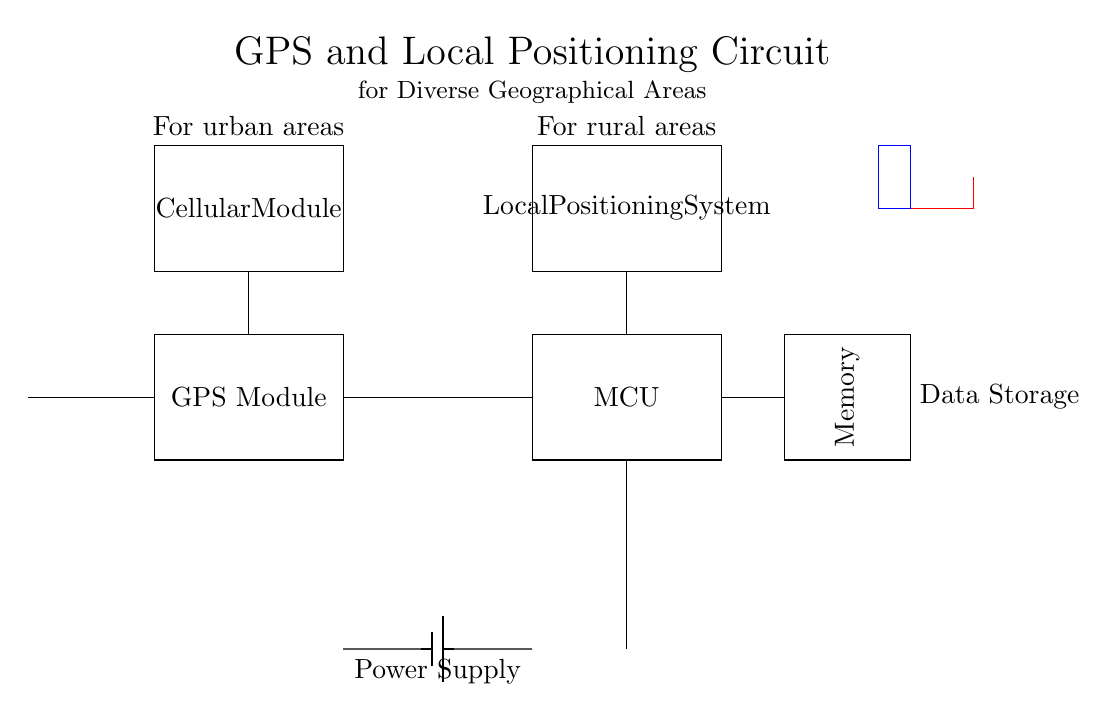What component is used for geographical positioning? The GPS Module is clearly labeled in the circuit diagram as a component responsible for geographical positioning.
Answer: GPS Module What is the power supply for this circuit? The Battery is depicted in the lower part of the circuit diagram and serves as the power source for the entire setup.
Answer: Battery What is the purpose of the Cellular Module? The Cellular Module allows for communication, particularly in urban areas, as indicated by the note above it in the diagram.
Answer: Communication How does the Local Positioning System interact with the Microcontroller? The diagram shows a direct connection from the Local Positioning System to the Microcontroller, indicating that data from local positioning is processed by the MCU.
Answer: Direct connection What are the two operational environments labeled in the circuit diagram? The diagram differentiates areas by indicating one module for urban areas and another for rural areas, both labeled accordingly.
Answer: Urban and rural What is the function of the Memory component? The Memory component is shown to be connected to the Microcontroller, indicating that it stores data processed by the MCU, essential for tracking purposes.
Answer: Data storage In what way does the Texas flag symbol relate to the circuit's application? The symbol placed on the circuit implies that the circuit is tailored or significant to Texas, suggesting a regional focus for the GPS and positioning services.
Answer: Regional focus 